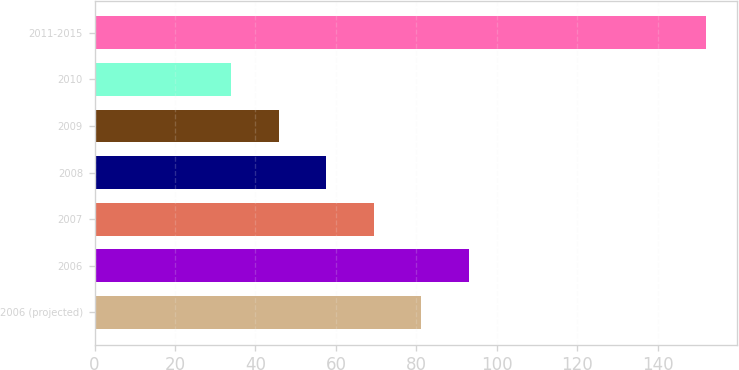Convert chart. <chart><loc_0><loc_0><loc_500><loc_500><bar_chart><fcel>2006 (projected)<fcel>2006<fcel>2007<fcel>2008<fcel>2009<fcel>2010<fcel>2011-2015<nl><fcel>81.2<fcel>93<fcel>69.4<fcel>57.6<fcel>45.8<fcel>34<fcel>152<nl></chart> 